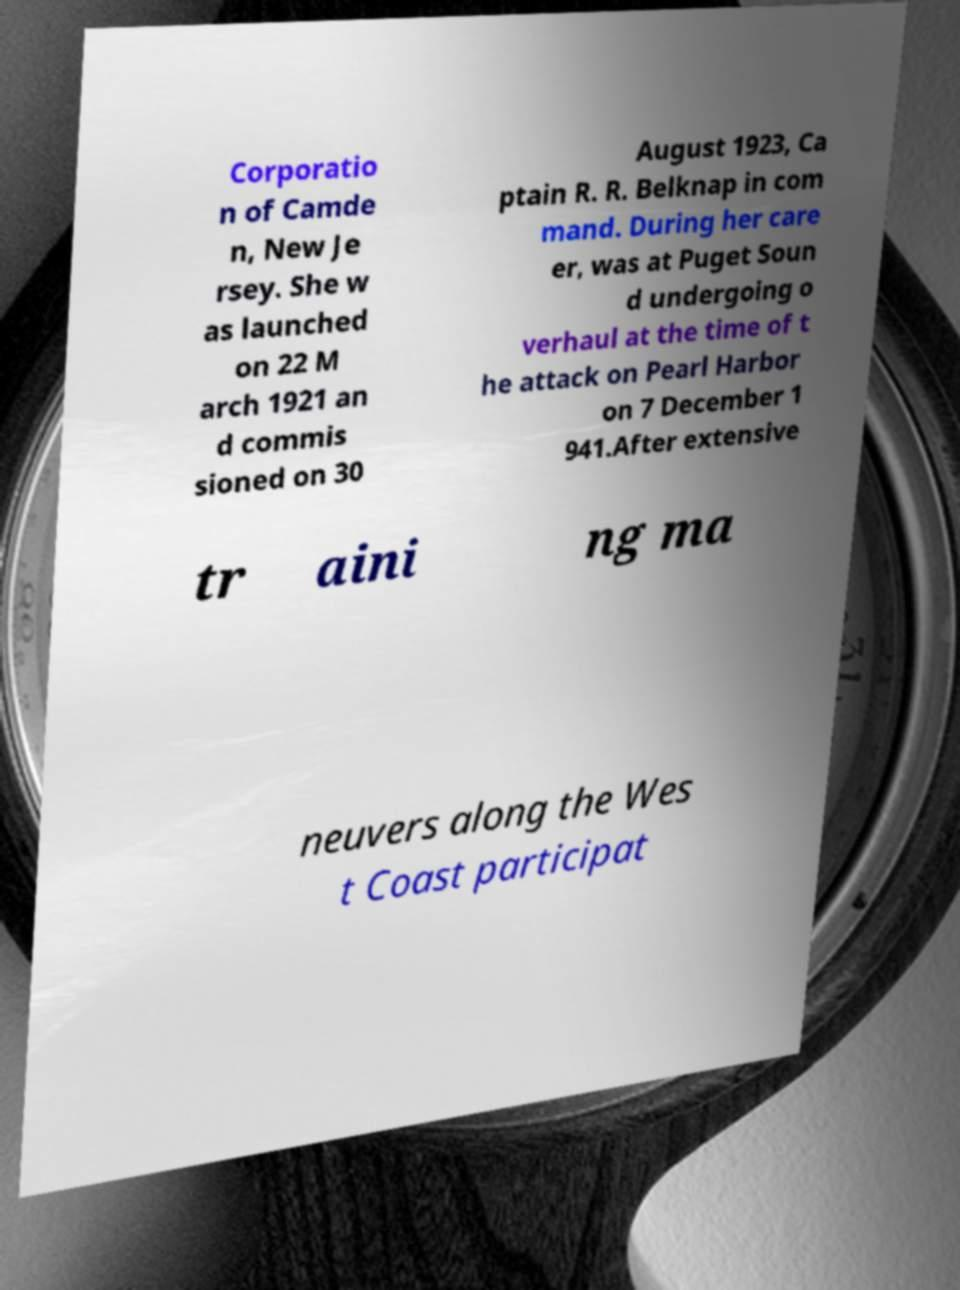Please identify and transcribe the text found in this image. Corporatio n of Camde n, New Je rsey. She w as launched on 22 M arch 1921 an d commis sioned on 30 August 1923, Ca ptain R. R. Belknap in com mand. During her care er, was at Puget Soun d undergoing o verhaul at the time of t he attack on Pearl Harbor on 7 December 1 941.After extensive tr aini ng ma neuvers along the Wes t Coast participat 